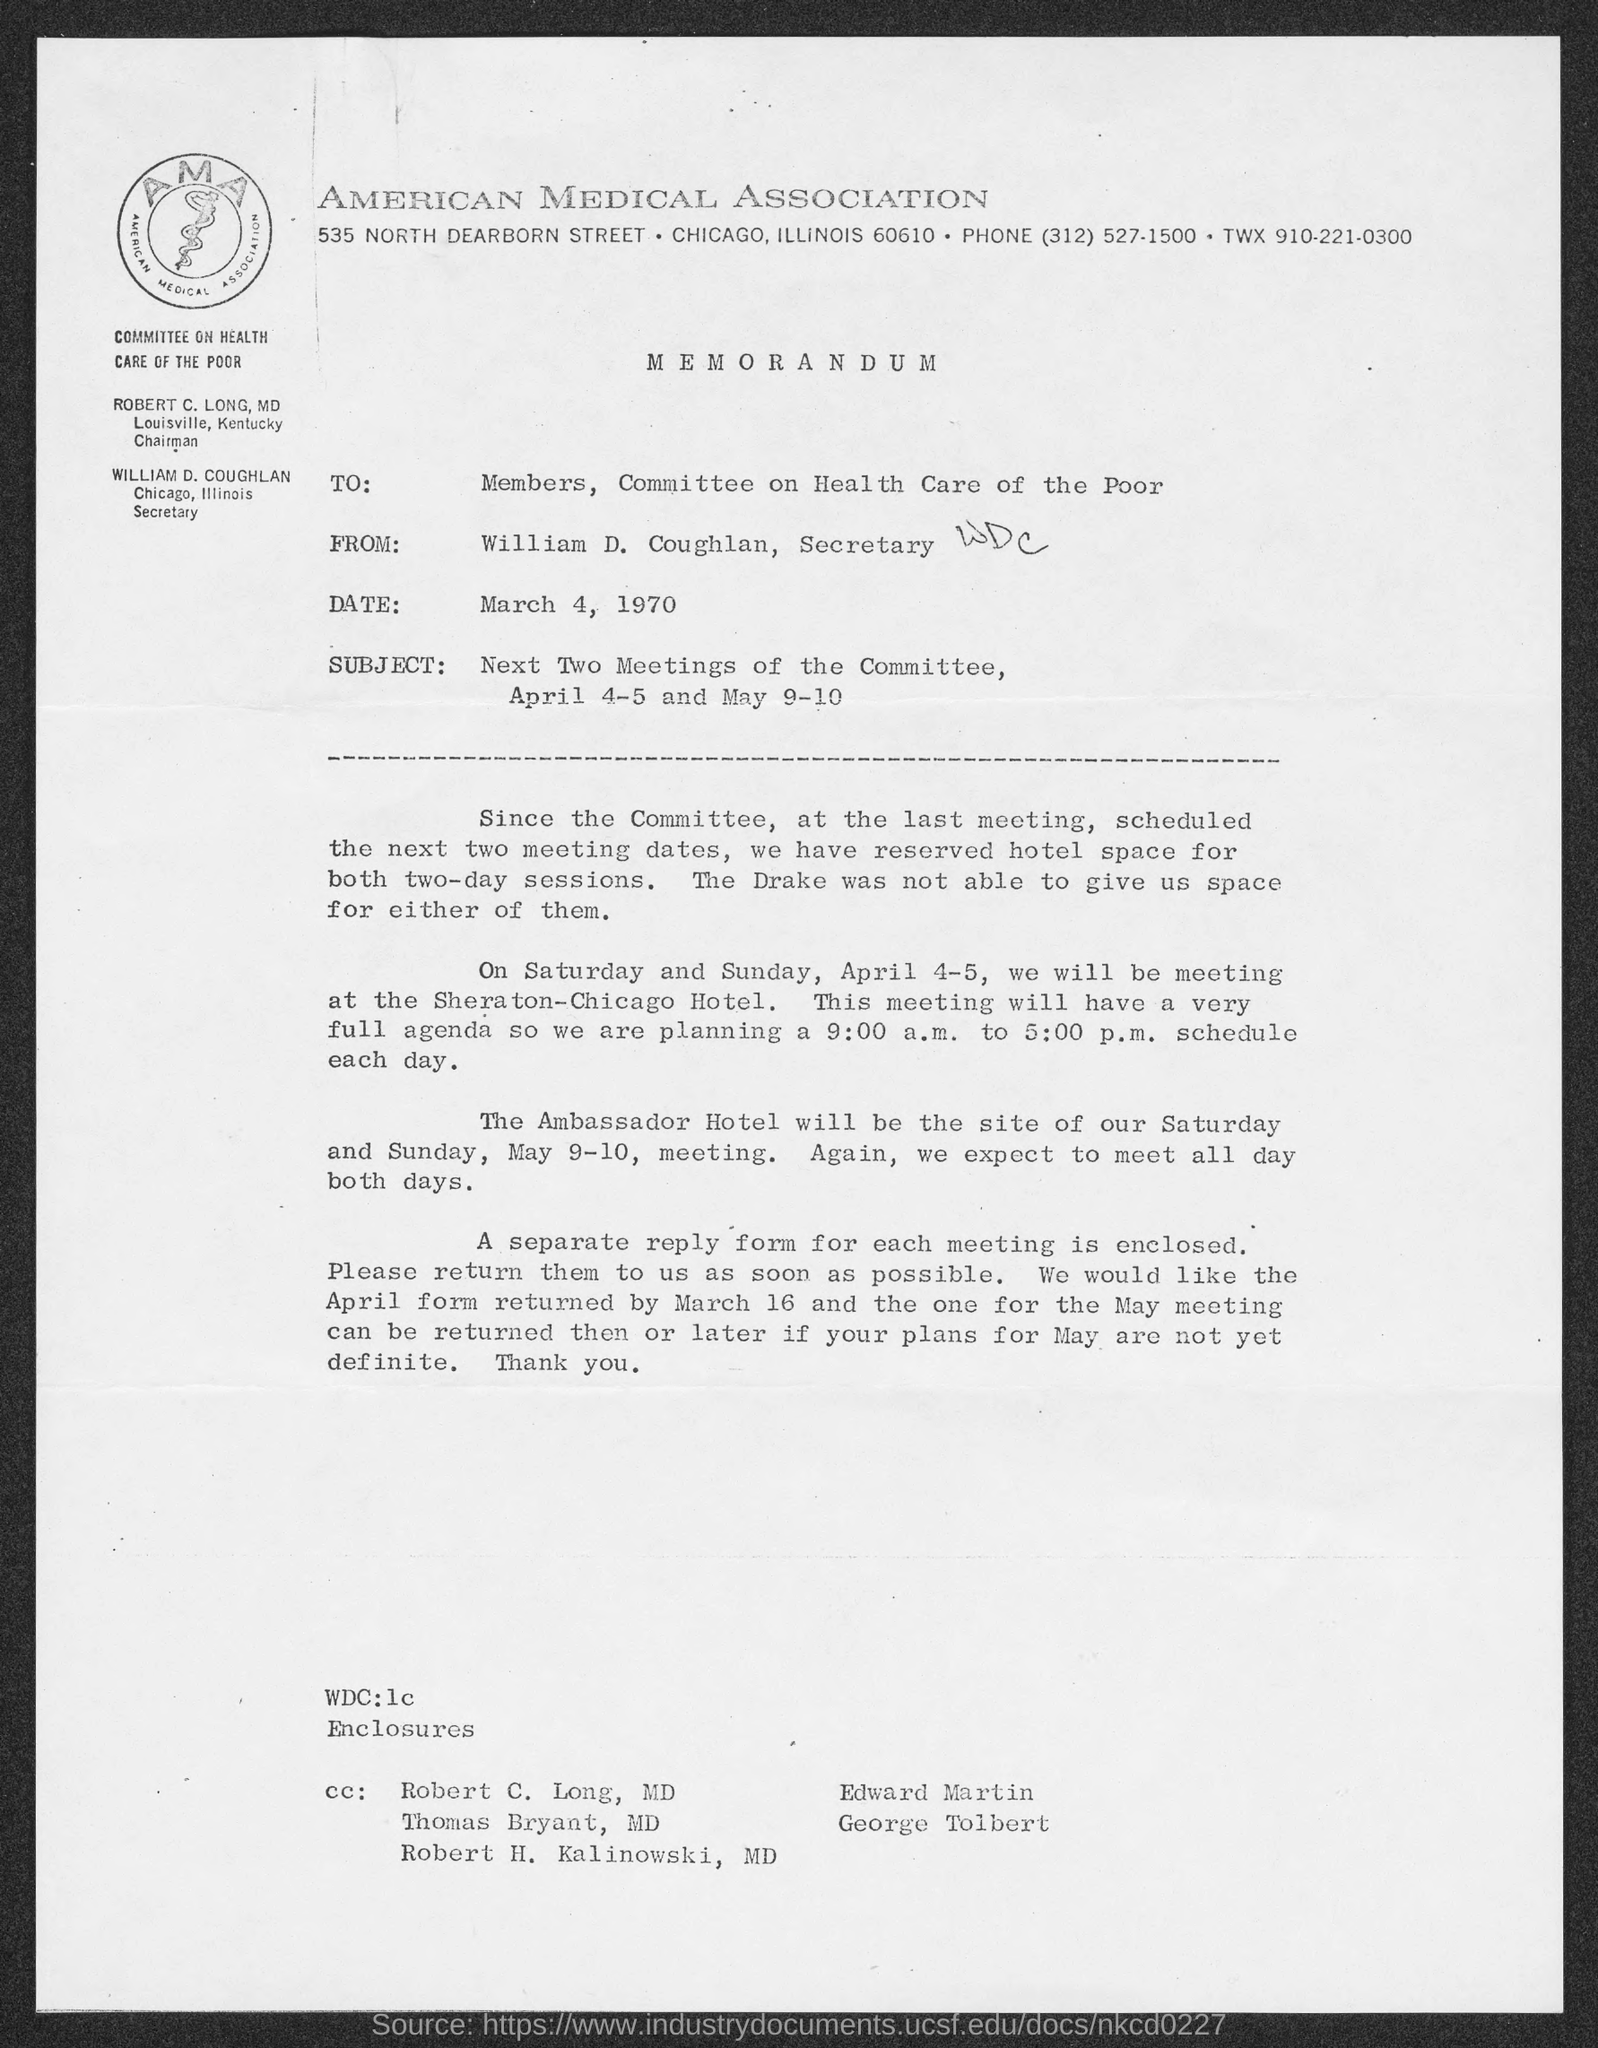What is the phone no. of american  medical association ?
Provide a short and direct response. (312) 527-1500. In which city is american medical association at ?
Your answer should be compact. Chicago. When is the memorandum dated?
Offer a very short reply. March 4, 1970. What is the from address in memorandum ?
Ensure brevity in your answer.  William D. Coughlan. What is the position of william d. coughlan?
Provide a short and direct response. Secretary. 